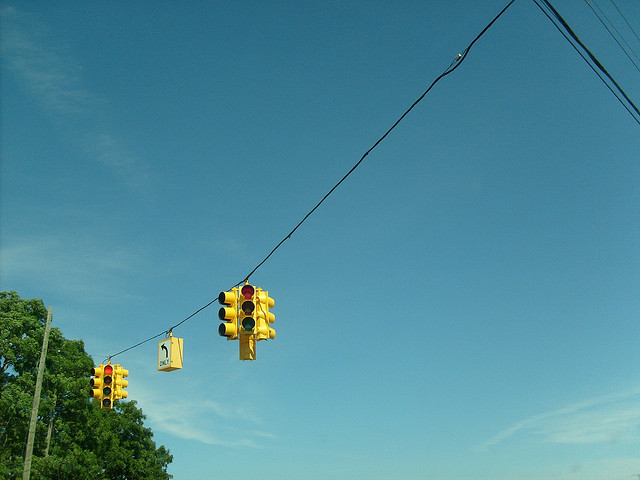Why are there so many lights? This particular setup with numerous traffic signals typically indicates a significant or busy intersection, possibly with multiple turn lanes or pedestrian crossings. Such arrangements are intended to enhance safety and improve the flow of both vehicular and pedestrian traffic. 